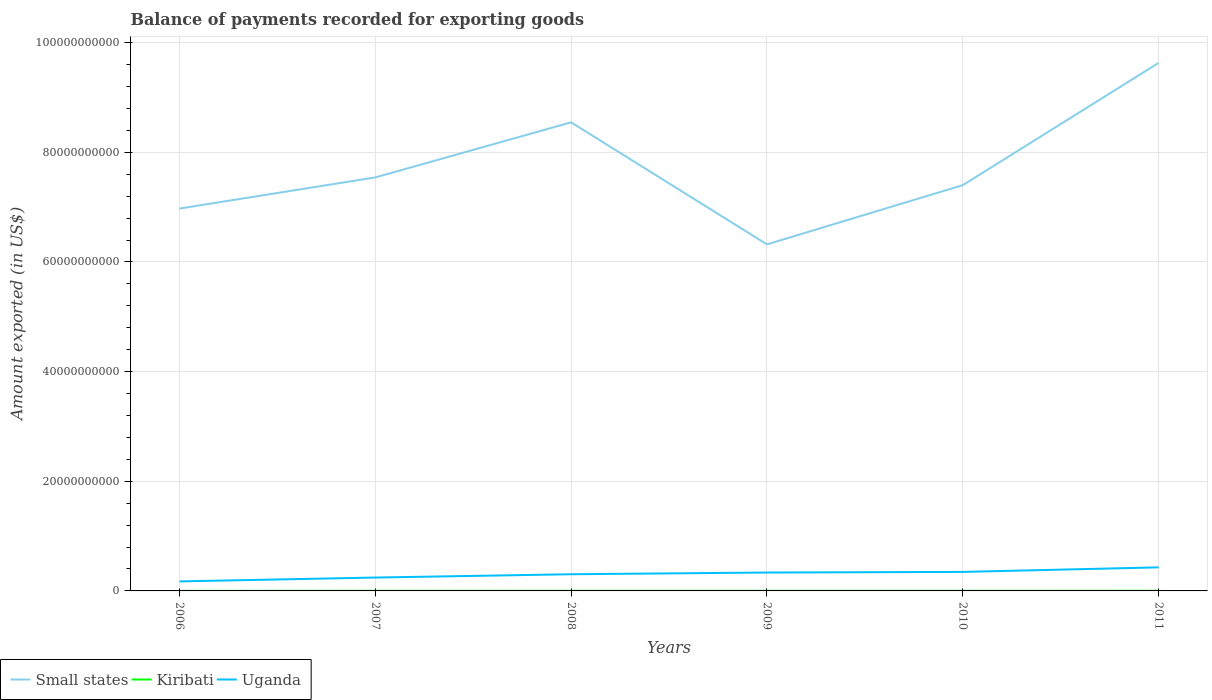How many different coloured lines are there?
Ensure brevity in your answer.  3. Across all years, what is the maximum amount exported in Small states?
Provide a short and direct response. 6.32e+1. What is the total amount exported in Kiribati in the graph?
Your response must be concise. -4.42e+06. What is the difference between the highest and the second highest amount exported in Uganda?
Make the answer very short. 2.56e+09. How many lines are there?
Your answer should be very brief. 3. What is the difference between two consecutive major ticks on the Y-axis?
Offer a very short reply. 2.00e+1. Are the values on the major ticks of Y-axis written in scientific E-notation?
Provide a succinct answer. No. Does the graph contain any zero values?
Your response must be concise. No. Does the graph contain grids?
Provide a succinct answer. Yes. How are the legend labels stacked?
Your response must be concise. Horizontal. What is the title of the graph?
Ensure brevity in your answer.  Balance of payments recorded for exporting goods. Does "Uganda" appear as one of the legend labels in the graph?
Keep it short and to the point. Yes. What is the label or title of the Y-axis?
Keep it short and to the point. Amount exported (in US$). What is the Amount exported (in US$) in Small states in 2006?
Your answer should be very brief. 6.97e+1. What is the Amount exported (in US$) of Kiribati in 2006?
Make the answer very short. 1.19e+07. What is the Amount exported (in US$) in Uganda in 2006?
Provide a succinct answer. 1.74e+09. What is the Amount exported (in US$) in Small states in 2007?
Your response must be concise. 7.54e+1. What is the Amount exported (in US$) in Kiribati in 2007?
Provide a succinct answer. 2.19e+07. What is the Amount exported (in US$) of Uganda in 2007?
Offer a very short reply. 2.44e+09. What is the Amount exported (in US$) of Small states in 2008?
Keep it short and to the point. 8.55e+1. What is the Amount exported (in US$) in Kiribati in 2008?
Keep it short and to the point. 2.17e+07. What is the Amount exported (in US$) of Uganda in 2008?
Give a very brief answer. 3.04e+09. What is the Amount exported (in US$) of Small states in 2009?
Provide a short and direct response. 6.32e+1. What is the Amount exported (in US$) of Kiribati in 2009?
Offer a very short reply. 1.99e+07. What is the Amount exported (in US$) in Uganda in 2009?
Your response must be concise. 3.35e+09. What is the Amount exported (in US$) of Small states in 2010?
Give a very brief answer. 7.40e+1. What is the Amount exported (in US$) in Kiribati in 2010?
Your answer should be compact. 1.96e+07. What is the Amount exported (in US$) of Uganda in 2010?
Offer a very short reply. 3.47e+09. What is the Amount exported (in US$) of Small states in 2011?
Keep it short and to the point. 9.63e+1. What is the Amount exported (in US$) in Kiribati in 2011?
Your answer should be very brief. 2.61e+07. What is the Amount exported (in US$) in Uganda in 2011?
Keep it short and to the point. 4.30e+09. Across all years, what is the maximum Amount exported (in US$) of Small states?
Your answer should be very brief. 9.63e+1. Across all years, what is the maximum Amount exported (in US$) in Kiribati?
Provide a short and direct response. 2.61e+07. Across all years, what is the maximum Amount exported (in US$) in Uganda?
Make the answer very short. 4.30e+09. Across all years, what is the minimum Amount exported (in US$) of Small states?
Offer a terse response. 6.32e+1. Across all years, what is the minimum Amount exported (in US$) of Kiribati?
Your answer should be compact. 1.19e+07. Across all years, what is the minimum Amount exported (in US$) of Uganda?
Your response must be concise. 1.74e+09. What is the total Amount exported (in US$) in Small states in the graph?
Ensure brevity in your answer.  4.64e+11. What is the total Amount exported (in US$) in Kiribati in the graph?
Offer a terse response. 1.21e+08. What is the total Amount exported (in US$) of Uganda in the graph?
Your answer should be compact. 1.83e+1. What is the difference between the Amount exported (in US$) of Small states in 2006 and that in 2007?
Provide a succinct answer. -5.68e+09. What is the difference between the Amount exported (in US$) of Kiribati in 2006 and that in 2007?
Provide a short and direct response. -9.96e+06. What is the difference between the Amount exported (in US$) of Uganda in 2006 and that in 2007?
Your response must be concise. -7.03e+08. What is the difference between the Amount exported (in US$) of Small states in 2006 and that in 2008?
Your answer should be compact. -1.57e+1. What is the difference between the Amount exported (in US$) in Kiribati in 2006 and that in 2008?
Offer a terse response. -9.77e+06. What is the difference between the Amount exported (in US$) of Uganda in 2006 and that in 2008?
Your response must be concise. -1.30e+09. What is the difference between the Amount exported (in US$) in Small states in 2006 and that in 2009?
Your response must be concise. 6.53e+09. What is the difference between the Amount exported (in US$) in Kiribati in 2006 and that in 2009?
Offer a terse response. -8.03e+06. What is the difference between the Amount exported (in US$) of Uganda in 2006 and that in 2009?
Your response must be concise. -1.62e+09. What is the difference between the Amount exported (in US$) in Small states in 2006 and that in 2010?
Your answer should be compact. -4.26e+09. What is the difference between the Amount exported (in US$) in Kiribati in 2006 and that in 2010?
Offer a very short reply. -7.64e+06. What is the difference between the Amount exported (in US$) in Uganda in 2006 and that in 2010?
Provide a short and direct response. -1.73e+09. What is the difference between the Amount exported (in US$) of Small states in 2006 and that in 2011?
Provide a short and direct response. -2.66e+1. What is the difference between the Amount exported (in US$) of Kiribati in 2006 and that in 2011?
Your response must be concise. -1.42e+07. What is the difference between the Amount exported (in US$) in Uganda in 2006 and that in 2011?
Ensure brevity in your answer.  -2.56e+09. What is the difference between the Amount exported (in US$) in Small states in 2007 and that in 2008?
Your answer should be compact. -1.00e+1. What is the difference between the Amount exported (in US$) in Kiribati in 2007 and that in 2008?
Your answer should be very brief. 1.91e+05. What is the difference between the Amount exported (in US$) in Uganda in 2007 and that in 2008?
Your answer should be very brief. -6.01e+08. What is the difference between the Amount exported (in US$) in Small states in 2007 and that in 2009?
Provide a short and direct response. 1.22e+1. What is the difference between the Amount exported (in US$) of Kiribati in 2007 and that in 2009?
Offer a very short reply. 1.93e+06. What is the difference between the Amount exported (in US$) in Uganda in 2007 and that in 2009?
Ensure brevity in your answer.  -9.15e+08. What is the difference between the Amount exported (in US$) of Small states in 2007 and that in 2010?
Provide a succinct answer. 1.42e+09. What is the difference between the Amount exported (in US$) in Kiribati in 2007 and that in 2010?
Make the answer very short. 2.32e+06. What is the difference between the Amount exported (in US$) of Uganda in 2007 and that in 2010?
Give a very brief answer. -1.03e+09. What is the difference between the Amount exported (in US$) of Small states in 2007 and that in 2011?
Make the answer very short. -2.09e+1. What is the difference between the Amount exported (in US$) in Kiribati in 2007 and that in 2011?
Ensure brevity in your answer.  -4.23e+06. What is the difference between the Amount exported (in US$) of Uganda in 2007 and that in 2011?
Provide a short and direct response. -1.86e+09. What is the difference between the Amount exported (in US$) in Small states in 2008 and that in 2009?
Keep it short and to the point. 2.23e+1. What is the difference between the Amount exported (in US$) of Kiribati in 2008 and that in 2009?
Make the answer very short. 1.74e+06. What is the difference between the Amount exported (in US$) of Uganda in 2008 and that in 2009?
Offer a very short reply. -3.14e+08. What is the difference between the Amount exported (in US$) of Small states in 2008 and that in 2010?
Ensure brevity in your answer.  1.15e+1. What is the difference between the Amount exported (in US$) of Kiribati in 2008 and that in 2010?
Your answer should be very brief. 2.13e+06. What is the difference between the Amount exported (in US$) of Uganda in 2008 and that in 2010?
Your answer should be compact. -4.28e+08. What is the difference between the Amount exported (in US$) of Small states in 2008 and that in 2011?
Provide a succinct answer. -1.08e+1. What is the difference between the Amount exported (in US$) in Kiribati in 2008 and that in 2011?
Provide a short and direct response. -4.42e+06. What is the difference between the Amount exported (in US$) of Uganda in 2008 and that in 2011?
Provide a short and direct response. -1.26e+09. What is the difference between the Amount exported (in US$) of Small states in 2009 and that in 2010?
Offer a very short reply. -1.08e+1. What is the difference between the Amount exported (in US$) of Kiribati in 2009 and that in 2010?
Provide a short and direct response. 3.90e+05. What is the difference between the Amount exported (in US$) of Uganda in 2009 and that in 2010?
Your answer should be very brief. -1.14e+08. What is the difference between the Amount exported (in US$) of Small states in 2009 and that in 2011?
Offer a terse response. -3.31e+1. What is the difference between the Amount exported (in US$) of Kiribati in 2009 and that in 2011?
Your answer should be very brief. -6.16e+06. What is the difference between the Amount exported (in US$) in Uganda in 2009 and that in 2011?
Provide a short and direct response. -9.44e+08. What is the difference between the Amount exported (in US$) in Small states in 2010 and that in 2011?
Your answer should be compact. -2.23e+1. What is the difference between the Amount exported (in US$) of Kiribati in 2010 and that in 2011?
Offer a very short reply. -6.55e+06. What is the difference between the Amount exported (in US$) in Uganda in 2010 and that in 2011?
Provide a short and direct response. -8.30e+08. What is the difference between the Amount exported (in US$) in Small states in 2006 and the Amount exported (in US$) in Kiribati in 2007?
Your response must be concise. 6.97e+1. What is the difference between the Amount exported (in US$) in Small states in 2006 and the Amount exported (in US$) in Uganda in 2007?
Ensure brevity in your answer.  6.73e+1. What is the difference between the Amount exported (in US$) of Kiribati in 2006 and the Amount exported (in US$) of Uganda in 2007?
Make the answer very short. -2.43e+09. What is the difference between the Amount exported (in US$) in Small states in 2006 and the Amount exported (in US$) in Kiribati in 2008?
Your answer should be very brief. 6.97e+1. What is the difference between the Amount exported (in US$) of Small states in 2006 and the Amount exported (in US$) of Uganda in 2008?
Make the answer very short. 6.67e+1. What is the difference between the Amount exported (in US$) of Kiribati in 2006 and the Amount exported (in US$) of Uganda in 2008?
Give a very brief answer. -3.03e+09. What is the difference between the Amount exported (in US$) in Small states in 2006 and the Amount exported (in US$) in Kiribati in 2009?
Offer a terse response. 6.97e+1. What is the difference between the Amount exported (in US$) in Small states in 2006 and the Amount exported (in US$) in Uganda in 2009?
Ensure brevity in your answer.  6.64e+1. What is the difference between the Amount exported (in US$) of Kiribati in 2006 and the Amount exported (in US$) of Uganda in 2009?
Your answer should be compact. -3.34e+09. What is the difference between the Amount exported (in US$) in Small states in 2006 and the Amount exported (in US$) in Kiribati in 2010?
Offer a very short reply. 6.97e+1. What is the difference between the Amount exported (in US$) in Small states in 2006 and the Amount exported (in US$) in Uganda in 2010?
Give a very brief answer. 6.63e+1. What is the difference between the Amount exported (in US$) in Kiribati in 2006 and the Amount exported (in US$) in Uganda in 2010?
Your answer should be compact. -3.46e+09. What is the difference between the Amount exported (in US$) of Small states in 2006 and the Amount exported (in US$) of Kiribati in 2011?
Keep it short and to the point. 6.97e+1. What is the difference between the Amount exported (in US$) of Small states in 2006 and the Amount exported (in US$) of Uganda in 2011?
Your response must be concise. 6.54e+1. What is the difference between the Amount exported (in US$) of Kiribati in 2006 and the Amount exported (in US$) of Uganda in 2011?
Your answer should be very brief. -4.29e+09. What is the difference between the Amount exported (in US$) in Small states in 2007 and the Amount exported (in US$) in Kiribati in 2008?
Give a very brief answer. 7.54e+1. What is the difference between the Amount exported (in US$) of Small states in 2007 and the Amount exported (in US$) of Uganda in 2008?
Offer a very short reply. 7.24e+1. What is the difference between the Amount exported (in US$) in Kiribati in 2007 and the Amount exported (in US$) in Uganda in 2008?
Make the answer very short. -3.02e+09. What is the difference between the Amount exported (in US$) of Small states in 2007 and the Amount exported (in US$) of Kiribati in 2009?
Offer a terse response. 7.54e+1. What is the difference between the Amount exported (in US$) in Small states in 2007 and the Amount exported (in US$) in Uganda in 2009?
Provide a succinct answer. 7.21e+1. What is the difference between the Amount exported (in US$) in Kiribati in 2007 and the Amount exported (in US$) in Uganda in 2009?
Offer a very short reply. -3.33e+09. What is the difference between the Amount exported (in US$) in Small states in 2007 and the Amount exported (in US$) in Kiribati in 2010?
Offer a terse response. 7.54e+1. What is the difference between the Amount exported (in US$) of Small states in 2007 and the Amount exported (in US$) of Uganda in 2010?
Give a very brief answer. 7.20e+1. What is the difference between the Amount exported (in US$) of Kiribati in 2007 and the Amount exported (in US$) of Uganda in 2010?
Your answer should be very brief. -3.45e+09. What is the difference between the Amount exported (in US$) of Small states in 2007 and the Amount exported (in US$) of Kiribati in 2011?
Provide a short and direct response. 7.54e+1. What is the difference between the Amount exported (in US$) in Small states in 2007 and the Amount exported (in US$) in Uganda in 2011?
Provide a succinct answer. 7.11e+1. What is the difference between the Amount exported (in US$) in Kiribati in 2007 and the Amount exported (in US$) in Uganda in 2011?
Ensure brevity in your answer.  -4.28e+09. What is the difference between the Amount exported (in US$) in Small states in 2008 and the Amount exported (in US$) in Kiribati in 2009?
Your response must be concise. 8.55e+1. What is the difference between the Amount exported (in US$) in Small states in 2008 and the Amount exported (in US$) in Uganda in 2009?
Ensure brevity in your answer.  8.21e+1. What is the difference between the Amount exported (in US$) of Kiribati in 2008 and the Amount exported (in US$) of Uganda in 2009?
Keep it short and to the point. -3.33e+09. What is the difference between the Amount exported (in US$) in Small states in 2008 and the Amount exported (in US$) in Kiribati in 2010?
Keep it short and to the point. 8.55e+1. What is the difference between the Amount exported (in US$) in Small states in 2008 and the Amount exported (in US$) in Uganda in 2010?
Make the answer very short. 8.20e+1. What is the difference between the Amount exported (in US$) in Kiribati in 2008 and the Amount exported (in US$) in Uganda in 2010?
Give a very brief answer. -3.45e+09. What is the difference between the Amount exported (in US$) of Small states in 2008 and the Amount exported (in US$) of Kiribati in 2011?
Make the answer very short. 8.54e+1. What is the difference between the Amount exported (in US$) in Small states in 2008 and the Amount exported (in US$) in Uganda in 2011?
Provide a succinct answer. 8.12e+1. What is the difference between the Amount exported (in US$) in Kiribati in 2008 and the Amount exported (in US$) in Uganda in 2011?
Make the answer very short. -4.28e+09. What is the difference between the Amount exported (in US$) in Small states in 2009 and the Amount exported (in US$) in Kiribati in 2010?
Provide a succinct answer. 6.32e+1. What is the difference between the Amount exported (in US$) in Small states in 2009 and the Amount exported (in US$) in Uganda in 2010?
Your answer should be very brief. 5.97e+1. What is the difference between the Amount exported (in US$) of Kiribati in 2009 and the Amount exported (in US$) of Uganda in 2010?
Offer a terse response. -3.45e+09. What is the difference between the Amount exported (in US$) of Small states in 2009 and the Amount exported (in US$) of Kiribati in 2011?
Make the answer very short. 6.32e+1. What is the difference between the Amount exported (in US$) in Small states in 2009 and the Amount exported (in US$) in Uganda in 2011?
Provide a short and direct response. 5.89e+1. What is the difference between the Amount exported (in US$) of Kiribati in 2009 and the Amount exported (in US$) of Uganda in 2011?
Provide a succinct answer. -4.28e+09. What is the difference between the Amount exported (in US$) of Small states in 2010 and the Amount exported (in US$) of Kiribati in 2011?
Offer a very short reply. 7.40e+1. What is the difference between the Amount exported (in US$) of Small states in 2010 and the Amount exported (in US$) of Uganda in 2011?
Keep it short and to the point. 6.97e+1. What is the difference between the Amount exported (in US$) of Kiribati in 2010 and the Amount exported (in US$) of Uganda in 2011?
Make the answer very short. -4.28e+09. What is the average Amount exported (in US$) in Small states per year?
Give a very brief answer. 7.74e+1. What is the average Amount exported (in US$) of Kiribati per year?
Your answer should be compact. 2.02e+07. What is the average Amount exported (in US$) in Uganda per year?
Make the answer very short. 3.06e+09. In the year 2006, what is the difference between the Amount exported (in US$) in Small states and Amount exported (in US$) in Kiribati?
Your answer should be compact. 6.97e+1. In the year 2006, what is the difference between the Amount exported (in US$) in Small states and Amount exported (in US$) in Uganda?
Keep it short and to the point. 6.80e+1. In the year 2006, what is the difference between the Amount exported (in US$) in Kiribati and Amount exported (in US$) in Uganda?
Your answer should be compact. -1.72e+09. In the year 2007, what is the difference between the Amount exported (in US$) of Small states and Amount exported (in US$) of Kiribati?
Make the answer very short. 7.54e+1. In the year 2007, what is the difference between the Amount exported (in US$) in Small states and Amount exported (in US$) in Uganda?
Keep it short and to the point. 7.30e+1. In the year 2007, what is the difference between the Amount exported (in US$) of Kiribati and Amount exported (in US$) of Uganda?
Your answer should be very brief. -2.42e+09. In the year 2008, what is the difference between the Amount exported (in US$) in Small states and Amount exported (in US$) in Kiribati?
Provide a short and direct response. 8.54e+1. In the year 2008, what is the difference between the Amount exported (in US$) of Small states and Amount exported (in US$) of Uganda?
Offer a very short reply. 8.24e+1. In the year 2008, what is the difference between the Amount exported (in US$) in Kiribati and Amount exported (in US$) in Uganda?
Provide a succinct answer. -3.02e+09. In the year 2009, what is the difference between the Amount exported (in US$) in Small states and Amount exported (in US$) in Kiribati?
Offer a very short reply. 6.32e+1. In the year 2009, what is the difference between the Amount exported (in US$) of Small states and Amount exported (in US$) of Uganda?
Offer a very short reply. 5.99e+1. In the year 2009, what is the difference between the Amount exported (in US$) in Kiribati and Amount exported (in US$) in Uganda?
Ensure brevity in your answer.  -3.33e+09. In the year 2010, what is the difference between the Amount exported (in US$) of Small states and Amount exported (in US$) of Kiribati?
Your answer should be compact. 7.40e+1. In the year 2010, what is the difference between the Amount exported (in US$) in Small states and Amount exported (in US$) in Uganda?
Your answer should be very brief. 7.05e+1. In the year 2010, what is the difference between the Amount exported (in US$) of Kiribati and Amount exported (in US$) of Uganda?
Provide a succinct answer. -3.45e+09. In the year 2011, what is the difference between the Amount exported (in US$) in Small states and Amount exported (in US$) in Kiribati?
Your answer should be compact. 9.63e+1. In the year 2011, what is the difference between the Amount exported (in US$) in Small states and Amount exported (in US$) in Uganda?
Your response must be concise. 9.20e+1. In the year 2011, what is the difference between the Amount exported (in US$) of Kiribati and Amount exported (in US$) of Uganda?
Your answer should be compact. -4.27e+09. What is the ratio of the Amount exported (in US$) of Small states in 2006 to that in 2007?
Provide a succinct answer. 0.92. What is the ratio of the Amount exported (in US$) in Kiribati in 2006 to that in 2007?
Offer a very short reply. 0.54. What is the ratio of the Amount exported (in US$) of Uganda in 2006 to that in 2007?
Keep it short and to the point. 0.71. What is the ratio of the Amount exported (in US$) in Small states in 2006 to that in 2008?
Offer a very short reply. 0.82. What is the ratio of the Amount exported (in US$) in Kiribati in 2006 to that in 2008?
Give a very brief answer. 0.55. What is the ratio of the Amount exported (in US$) of Uganda in 2006 to that in 2008?
Your answer should be compact. 0.57. What is the ratio of the Amount exported (in US$) of Small states in 2006 to that in 2009?
Give a very brief answer. 1.1. What is the ratio of the Amount exported (in US$) in Kiribati in 2006 to that in 2009?
Provide a succinct answer. 0.6. What is the ratio of the Amount exported (in US$) in Uganda in 2006 to that in 2009?
Give a very brief answer. 0.52. What is the ratio of the Amount exported (in US$) of Small states in 2006 to that in 2010?
Provide a succinct answer. 0.94. What is the ratio of the Amount exported (in US$) of Kiribati in 2006 to that in 2010?
Give a very brief answer. 0.61. What is the ratio of the Amount exported (in US$) in Uganda in 2006 to that in 2010?
Give a very brief answer. 0.5. What is the ratio of the Amount exported (in US$) of Small states in 2006 to that in 2011?
Keep it short and to the point. 0.72. What is the ratio of the Amount exported (in US$) in Kiribati in 2006 to that in 2011?
Your answer should be very brief. 0.46. What is the ratio of the Amount exported (in US$) of Uganda in 2006 to that in 2011?
Your answer should be compact. 0.4. What is the ratio of the Amount exported (in US$) of Small states in 2007 to that in 2008?
Your answer should be compact. 0.88. What is the ratio of the Amount exported (in US$) in Kiribati in 2007 to that in 2008?
Provide a succinct answer. 1.01. What is the ratio of the Amount exported (in US$) of Uganda in 2007 to that in 2008?
Your response must be concise. 0.8. What is the ratio of the Amount exported (in US$) in Small states in 2007 to that in 2009?
Provide a short and direct response. 1.19. What is the ratio of the Amount exported (in US$) of Kiribati in 2007 to that in 2009?
Provide a succinct answer. 1.1. What is the ratio of the Amount exported (in US$) in Uganda in 2007 to that in 2009?
Give a very brief answer. 0.73. What is the ratio of the Amount exported (in US$) of Small states in 2007 to that in 2010?
Provide a succinct answer. 1.02. What is the ratio of the Amount exported (in US$) of Kiribati in 2007 to that in 2010?
Ensure brevity in your answer.  1.12. What is the ratio of the Amount exported (in US$) of Uganda in 2007 to that in 2010?
Your answer should be very brief. 0.7. What is the ratio of the Amount exported (in US$) in Small states in 2007 to that in 2011?
Provide a succinct answer. 0.78. What is the ratio of the Amount exported (in US$) of Kiribati in 2007 to that in 2011?
Make the answer very short. 0.84. What is the ratio of the Amount exported (in US$) of Uganda in 2007 to that in 2011?
Offer a terse response. 0.57. What is the ratio of the Amount exported (in US$) of Small states in 2008 to that in 2009?
Keep it short and to the point. 1.35. What is the ratio of the Amount exported (in US$) in Kiribati in 2008 to that in 2009?
Offer a very short reply. 1.09. What is the ratio of the Amount exported (in US$) in Uganda in 2008 to that in 2009?
Provide a succinct answer. 0.91. What is the ratio of the Amount exported (in US$) of Small states in 2008 to that in 2010?
Offer a terse response. 1.15. What is the ratio of the Amount exported (in US$) in Kiribati in 2008 to that in 2010?
Give a very brief answer. 1.11. What is the ratio of the Amount exported (in US$) in Uganda in 2008 to that in 2010?
Your answer should be very brief. 0.88. What is the ratio of the Amount exported (in US$) of Small states in 2008 to that in 2011?
Give a very brief answer. 0.89. What is the ratio of the Amount exported (in US$) of Kiribati in 2008 to that in 2011?
Keep it short and to the point. 0.83. What is the ratio of the Amount exported (in US$) in Uganda in 2008 to that in 2011?
Offer a terse response. 0.71. What is the ratio of the Amount exported (in US$) in Small states in 2009 to that in 2010?
Keep it short and to the point. 0.85. What is the ratio of the Amount exported (in US$) of Kiribati in 2009 to that in 2010?
Make the answer very short. 1.02. What is the ratio of the Amount exported (in US$) of Uganda in 2009 to that in 2010?
Offer a terse response. 0.97. What is the ratio of the Amount exported (in US$) in Small states in 2009 to that in 2011?
Keep it short and to the point. 0.66. What is the ratio of the Amount exported (in US$) in Kiribati in 2009 to that in 2011?
Provide a short and direct response. 0.76. What is the ratio of the Amount exported (in US$) in Uganda in 2009 to that in 2011?
Offer a very short reply. 0.78. What is the ratio of the Amount exported (in US$) of Small states in 2010 to that in 2011?
Your response must be concise. 0.77. What is the ratio of the Amount exported (in US$) of Kiribati in 2010 to that in 2011?
Offer a terse response. 0.75. What is the ratio of the Amount exported (in US$) of Uganda in 2010 to that in 2011?
Ensure brevity in your answer.  0.81. What is the difference between the highest and the second highest Amount exported (in US$) in Small states?
Keep it short and to the point. 1.08e+1. What is the difference between the highest and the second highest Amount exported (in US$) of Kiribati?
Keep it short and to the point. 4.23e+06. What is the difference between the highest and the second highest Amount exported (in US$) of Uganda?
Your answer should be very brief. 8.30e+08. What is the difference between the highest and the lowest Amount exported (in US$) in Small states?
Keep it short and to the point. 3.31e+1. What is the difference between the highest and the lowest Amount exported (in US$) of Kiribati?
Your response must be concise. 1.42e+07. What is the difference between the highest and the lowest Amount exported (in US$) of Uganda?
Make the answer very short. 2.56e+09. 